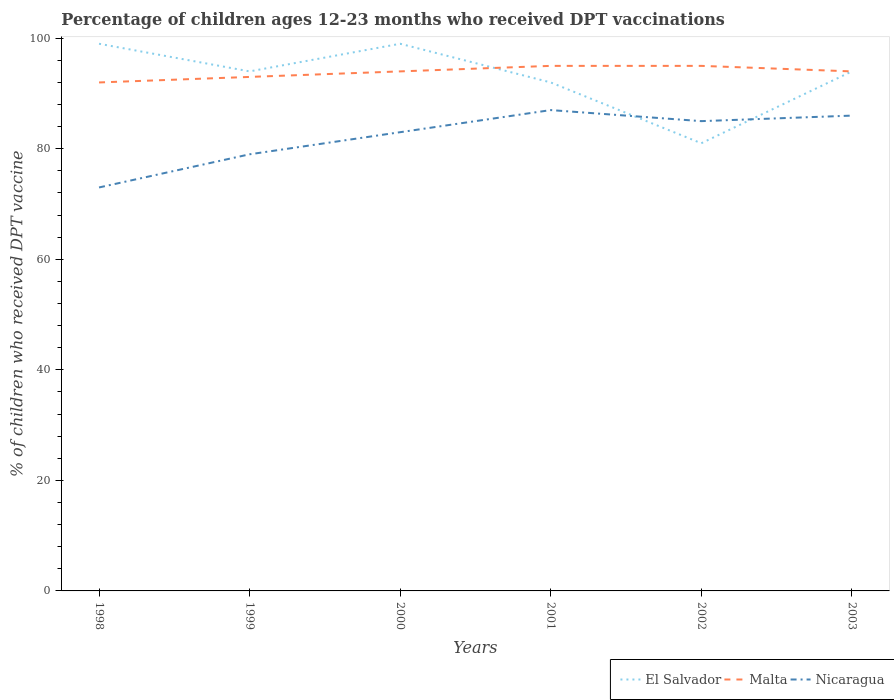How many different coloured lines are there?
Provide a succinct answer. 3. Across all years, what is the maximum percentage of children who received DPT vaccination in Nicaragua?
Your response must be concise. 73. In which year was the percentage of children who received DPT vaccination in Malta maximum?
Your answer should be compact. 1998. What is the total percentage of children who received DPT vaccination in Nicaragua in the graph?
Provide a short and direct response. -14. What is the difference between the highest and the second highest percentage of children who received DPT vaccination in Malta?
Make the answer very short. 3. What is the difference between the highest and the lowest percentage of children who received DPT vaccination in Malta?
Your answer should be very brief. 4. Is the percentage of children who received DPT vaccination in El Salvador strictly greater than the percentage of children who received DPT vaccination in Nicaragua over the years?
Ensure brevity in your answer.  No. How many years are there in the graph?
Provide a short and direct response. 6. Are the values on the major ticks of Y-axis written in scientific E-notation?
Give a very brief answer. No. How many legend labels are there?
Your answer should be compact. 3. What is the title of the graph?
Offer a very short reply. Percentage of children ages 12-23 months who received DPT vaccinations. Does "Australia" appear as one of the legend labels in the graph?
Provide a short and direct response. No. What is the label or title of the X-axis?
Your response must be concise. Years. What is the label or title of the Y-axis?
Give a very brief answer. % of children who received DPT vaccine. What is the % of children who received DPT vaccine in El Salvador in 1998?
Offer a very short reply. 99. What is the % of children who received DPT vaccine of Malta in 1998?
Ensure brevity in your answer.  92. What is the % of children who received DPT vaccine of El Salvador in 1999?
Your response must be concise. 94. What is the % of children who received DPT vaccine of Malta in 1999?
Provide a succinct answer. 93. What is the % of children who received DPT vaccine in Nicaragua in 1999?
Make the answer very short. 79. What is the % of children who received DPT vaccine of El Salvador in 2000?
Make the answer very short. 99. What is the % of children who received DPT vaccine of Malta in 2000?
Your response must be concise. 94. What is the % of children who received DPT vaccine in El Salvador in 2001?
Your response must be concise. 92. What is the % of children who received DPT vaccine in Malta in 2001?
Your response must be concise. 95. What is the % of children who received DPT vaccine in Malta in 2002?
Make the answer very short. 95. What is the % of children who received DPT vaccine of El Salvador in 2003?
Ensure brevity in your answer.  94. What is the % of children who received DPT vaccine in Malta in 2003?
Your answer should be compact. 94. Across all years, what is the maximum % of children who received DPT vaccine in Malta?
Keep it short and to the point. 95. Across all years, what is the maximum % of children who received DPT vaccine in Nicaragua?
Your answer should be very brief. 87. Across all years, what is the minimum % of children who received DPT vaccine in Malta?
Your answer should be very brief. 92. What is the total % of children who received DPT vaccine in El Salvador in the graph?
Offer a very short reply. 559. What is the total % of children who received DPT vaccine of Malta in the graph?
Your answer should be very brief. 563. What is the total % of children who received DPT vaccine of Nicaragua in the graph?
Make the answer very short. 493. What is the difference between the % of children who received DPT vaccine in Malta in 1998 and that in 1999?
Your response must be concise. -1. What is the difference between the % of children who received DPT vaccine in Malta in 1998 and that in 2000?
Ensure brevity in your answer.  -2. What is the difference between the % of children who received DPT vaccine of El Salvador in 1998 and that in 2001?
Your answer should be very brief. 7. What is the difference between the % of children who received DPT vaccine in Malta in 1998 and that in 2001?
Provide a short and direct response. -3. What is the difference between the % of children who received DPT vaccine of Nicaragua in 1998 and that in 2001?
Make the answer very short. -14. What is the difference between the % of children who received DPT vaccine in Malta in 1998 and that in 2002?
Provide a short and direct response. -3. What is the difference between the % of children who received DPT vaccine of El Salvador in 1998 and that in 2003?
Give a very brief answer. 5. What is the difference between the % of children who received DPT vaccine in Nicaragua in 1998 and that in 2003?
Provide a short and direct response. -13. What is the difference between the % of children who received DPT vaccine in El Salvador in 1999 and that in 2000?
Your response must be concise. -5. What is the difference between the % of children who received DPT vaccine of El Salvador in 1999 and that in 2001?
Offer a very short reply. 2. What is the difference between the % of children who received DPT vaccine of Malta in 1999 and that in 2002?
Your answer should be very brief. -2. What is the difference between the % of children who received DPT vaccine of Nicaragua in 1999 and that in 2002?
Provide a short and direct response. -6. What is the difference between the % of children who received DPT vaccine in El Salvador in 1999 and that in 2003?
Your response must be concise. 0. What is the difference between the % of children who received DPT vaccine of Nicaragua in 1999 and that in 2003?
Your answer should be very brief. -7. What is the difference between the % of children who received DPT vaccine of Nicaragua in 2000 and that in 2001?
Your answer should be very brief. -4. What is the difference between the % of children who received DPT vaccine in El Salvador in 2000 and that in 2002?
Your response must be concise. 18. What is the difference between the % of children who received DPT vaccine in Malta in 2000 and that in 2002?
Provide a succinct answer. -1. What is the difference between the % of children who received DPT vaccine of El Salvador in 2000 and that in 2003?
Your answer should be very brief. 5. What is the difference between the % of children who received DPT vaccine of Malta in 2000 and that in 2003?
Your response must be concise. 0. What is the difference between the % of children who received DPT vaccine of Nicaragua in 2000 and that in 2003?
Keep it short and to the point. -3. What is the difference between the % of children who received DPT vaccine of Malta in 2001 and that in 2002?
Provide a succinct answer. 0. What is the difference between the % of children who received DPT vaccine in El Salvador in 2002 and that in 2003?
Provide a succinct answer. -13. What is the difference between the % of children who received DPT vaccine in Malta in 2002 and that in 2003?
Make the answer very short. 1. What is the difference between the % of children who received DPT vaccine in El Salvador in 1998 and the % of children who received DPT vaccine in Malta in 1999?
Offer a terse response. 6. What is the difference between the % of children who received DPT vaccine in El Salvador in 1998 and the % of children who received DPT vaccine in Nicaragua in 1999?
Your answer should be very brief. 20. What is the difference between the % of children who received DPT vaccine in Malta in 1998 and the % of children who received DPT vaccine in Nicaragua in 1999?
Offer a very short reply. 13. What is the difference between the % of children who received DPT vaccine in El Salvador in 1998 and the % of children who received DPT vaccine in Malta in 2000?
Your answer should be compact. 5. What is the difference between the % of children who received DPT vaccine in Malta in 1998 and the % of children who received DPT vaccine in Nicaragua in 2000?
Provide a short and direct response. 9. What is the difference between the % of children who received DPT vaccine of El Salvador in 1998 and the % of children who received DPT vaccine of Nicaragua in 2001?
Keep it short and to the point. 12. What is the difference between the % of children who received DPT vaccine of El Salvador in 1998 and the % of children who received DPT vaccine of Malta in 2002?
Ensure brevity in your answer.  4. What is the difference between the % of children who received DPT vaccine of Malta in 1998 and the % of children who received DPT vaccine of Nicaragua in 2002?
Your response must be concise. 7. What is the difference between the % of children who received DPT vaccine in El Salvador in 1999 and the % of children who received DPT vaccine in Malta in 2000?
Give a very brief answer. 0. What is the difference between the % of children who received DPT vaccine in El Salvador in 1999 and the % of children who received DPT vaccine in Nicaragua in 2000?
Give a very brief answer. 11. What is the difference between the % of children who received DPT vaccine of El Salvador in 1999 and the % of children who received DPT vaccine of Nicaragua in 2001?
Your answer should be compact. 7. What is the difference between the % of children who received DPT vaccine in El Salvador in 1999 and the % of children who received DPT vaccine in Nicaragua in 2002?
Provide a short and direct response. 9. What is the difference between the % of children who received DPT vaccine in Malta in 1999 and the % of children who received DPT vaccine in Nicaragua in 2002?
Provide a succinct answer. 8. What is the difference between the % of children who received DPT vaccine of Malta in 2000 and the % of children who received DPT vaccine of Nicaragua in 2001?
Provide a short and direct response. 7. What is the difference between the % of children who received DPT vaccine of El Salvador in 2000 and the % of children who received DPT vaccine of Nicaragua in 2002?
Your answer should be very brief. 14. What is the difference between the % of children who received DPT vaccine in El Salvador in 2000 and the % of children who received DPT vaccine in Malta in 2003?
Your answer should be very brief. 5. What is the difference between the % of children who received DPT vaccine in El Salvador in 2001 and the % of children who received DPT vaccine in Nicaragua in 2002?
Offer a very short reply. 7. What is the difference between the % of children who received DPT vaccine in Malta in 2001 and the % of children who received DPT vaccine in Nicaragua in 2002?
Your answer should be very brief. 10. What is the difference between the % of children who received DPT vaccine in El Salvador in 2001 and the % of children who received DPT vaccine in Malta in 2003?
Offer a very short reply. -2. What is the difference between the % of children who received DPT vaccine in El Salvador in 2001 and the % of children who received DPT vaccine in Nicaragua in 2003?
Ensure brevity in your answer.  6. What is the difference between the % of children who received DPT vaccine in El Salvador in 2002 and the % of children who received DPT vaccine in Malta in 2003?
Give a very brief answer. -13. What is the difference between the % of children who received DPT vaccine in El Salvador in 2002 and the % of children who received DPT vaccine in Nicaragua in 2003?
Your answer should be very brief. -5. What is the average % of children who received DPT vaccine of El Salvador per year?
Provide a succinct answer. 93.17. What is the average % of children who received DPT vaccine in Malta per year?
Offer a very short reply. 93.83. What is the average % of children who received DPT vaccine in Nicaragua per year?
Your answer should be very brief. 82.17. In the year 1998, what is the difference between the % of children who received DPT vaccine of El Salvador and % of children who received DPT vaccine of Nicaragua?
Give a very brief answer. 26. In the year 1999, what is the difference between the % of children who received DPT vaccine of El Salvador and % of children who received DPT vaccine of Malta?
Provide a succinct answer. 1. In the year 1999, what is the difference between the % of children who received DPT vaccine of Malta and % of children who received DPT vaccine of Nicaragua?
Provide a succinct answer. 14. In the year 2001, what is the difference between the % of children who received DPT vaccine of El Salvador and % of children who received DPT vaccine of Nicaragua?
Offer a very short reply. 5. In the year 2001, what is the difference between the % of children who received DPT vaccine of Malta and % of children who received DPT vaccine of Nicaragua?
Make the answer very short. 8. In the year 2003, what is the difference between the % of children who received DPT vaccine in El Salvador and % of children who received DPT vaccine in Malta?
Offer a very short reply. 0. In the year 2003, what is the difference between the % of children who received DPT vaccine of El Salvador and % of children who received DPT vaccine of Nicaragua?
Keep it short and to the point. 8. What is the ratio of the % of children who received DPT vaccine of El Salvador in 1998 to that in 1999?
Provide a short and direct response. 1.05. What is the ratio of the % of children who received DPT vaccine in Malta in 1998 to that in 1999?
Your answer should be compact. 0.99. What is the ratio of the % of children who received DPT vaccine of Nicaragua in 1998 to that in 1999?
Your response must be concise. 0.92. What is the ratio of the % of children who received DPT vaccine in Malta in 1998 to that in 2000?
Provide a short and direct response. 0.98. What is the ratio of the % of children who received DPT vaccine in Nicaragua in 1998 to that in 2000?
Make the answer very short. 0.88. What is the ratio of the % of children who received DPT vaccine in El Salvador in 1998 to that in 2001?
Ensure brevity in your answer.  1.08. What is the ratio of the % of children who received DPT vaccine in Malta in 1998 to that in 2001?
Provide a succinct answer. 0.97. What is the ratio of the % of children who received DPT vaccine of Nicaragua in 1998 to that in 2001?
Offer a very short reply. 0.84. What is the ratio of the % of children who received DPT vaccine in El Salvador in 1998 to that in 2002?
Make the answer very short. 1.22. What is the ratio of the % of children who received DPT vaccine of Malta in 1998 to that in 2002?
Provide a short and direct response. 0.97. What is the ratio of the % of children who received DPT vaccine of Nicaragua in 1998 to that in 2002?
Make the answer very short. 0.86. What is the ratio of the % of children who received DPT vaccine in El Salvador in 1998 to that in 2003?
Offer a very short reply. 1.05. What is the ratio of the % of children who received DPT vaccine of Malta in 1998 to that in 2003?
Your response must be concise. 0.98. What is the ratio of the % of children who received DPT vaccine in Nicaragua in 1998 to that in 2003?
Your answer should be compact. 0.85. What is the ratio of the % of children who received DPT vaccine of El Salvador in 1999 to that in 2000?
Your answer should be very brief. 0.95. What is the ratio of the % of children who received DPT vaccine of Nicaragua in 1999 to that in 2000?
Provide a succinct answer. 0.95. What is the ratio of the % of children who received DPT vaccine of El Salvador in 1999 to that in 2001?
Your response must be concise. 1.02. What is the ratio of the % of children who received DPT vaccine of Malta in 1999 to that in 2001?
Your response must be concise. 0.98. What is the ratio of the % of children who received DPT vaccine in Nicaragua in 1999 to that in 2001?
Give a very brief answer. 0.91. What is the ratio of the % of children who received DPT vaccine of El Salvador in 1999 to that in 2002?
Keep it short and to the point. 1.16. What is the ratio of the % of children who received DPT vaccine of Malta in 1999 to that in 2002?
Provide a short and direct response. 0.98. What is the ratio of the % of children who received DPT vaccine of Nicaragua in 1999 to that in 2002?
Provide a short and direct response. 0.93. What is the ratio of the % of children who received DPT vaccine of El Salvador in 1999 to that in 2003?
Your answer should be compact. 1. What is the ratio of the % of children who received DPT vaccine of Malta in 1999 to that in 2003?
Your response must be concise. 0.99. What is the ratio of the % of children who received DPT vaccine of Nicaragua in 1999 to that in 2003?
Your answer should be compact. 0.92. What is the ratio of the % of children who received DPT vaccine of El Salvador in 2000 to that in 2001?
Your answer should be compact. 1.08. What is the ratio of the % of children who received DPT vaccine in Malta in 2000 to that in 2001?
Provide a short and direct response. 0.99. What is the ratio of the % of children who received DPT vaccine in Nicaragua in 2000 to that in 2001?
Provide a short and direct response. 0.95. What is the ratio of the % of children who received DPT vaccine of El Salvador in 2000 to that in 2002?
Ensure brevity in your answer.  1.22. What is the ratio of the % of children who received DPT vaccine of Malta in 2000 to that in 2002?
Provide a succinct answer. 0.99. What is the ratio of the % of children who received DPT vaccine in Nicaragua in 2000 to that in 2002?
Offer a terse response. 0.98. What is the ratio of the % of children who received DPT vaccine of El Salvador in 2000 to that in 2003?
Ensure brevity in your answer.  1.05. What is the ratio of the % of children who received DPT vaccine in Malta in 2000 to that in 2003?
Make the answer very short. 1. What is the ratio of the % of children who received DPT vaccine of Nicaragua in 2000 to that in 2003?
Your answer should be very brief. 0.97. What is the ratio of the % of children who received DPT vaccine in El Salvador in 2001 to that in 2002?
Offer a terse response. 1.14. What is the ratio of the % of children who received DPT vaccine in Malta in 2001 to that in 2002?
Ensure brevity in your answer.  1. What is the ratio of the % of children who received DPT vaccine of Nicaragua in 2001 to that in 2002?
Provide a succinct answer. 1.02. What is the ratio of the % of children who received DPT vaccine of El Salvador in 2001 to that in 2003?
Your answer should be compact. 0.98. What is the ratio of the % of children who received DPT vaccine of Malta in 2001 to that in 2003?
Keep it short and to the point. 1.01. What is the ratio of the % of children who received DPT vaccine in Nicaragua in 2001 to that in 2003?
Give a very brief answer. 1.01. What is the ratio of the % of children who received DPT vaccine of El Salvador in 2002 to that in 2003?
Your answer should be compact. 0.86. What is the ratio of the % of children who received DPT vaccine in Malta in 2002 to that in 2003?
Ensure brevity in your answer.  1.01. What is the ratio of the % of children who received DPT vaccine of Nicaragua in 2002 to that in 2003?
Make the answer very short. 0.99. What is the difference between the highest and the second highest % of children who received DPT vaccine of El Salvador?
Provide a succinct answer. 0. 